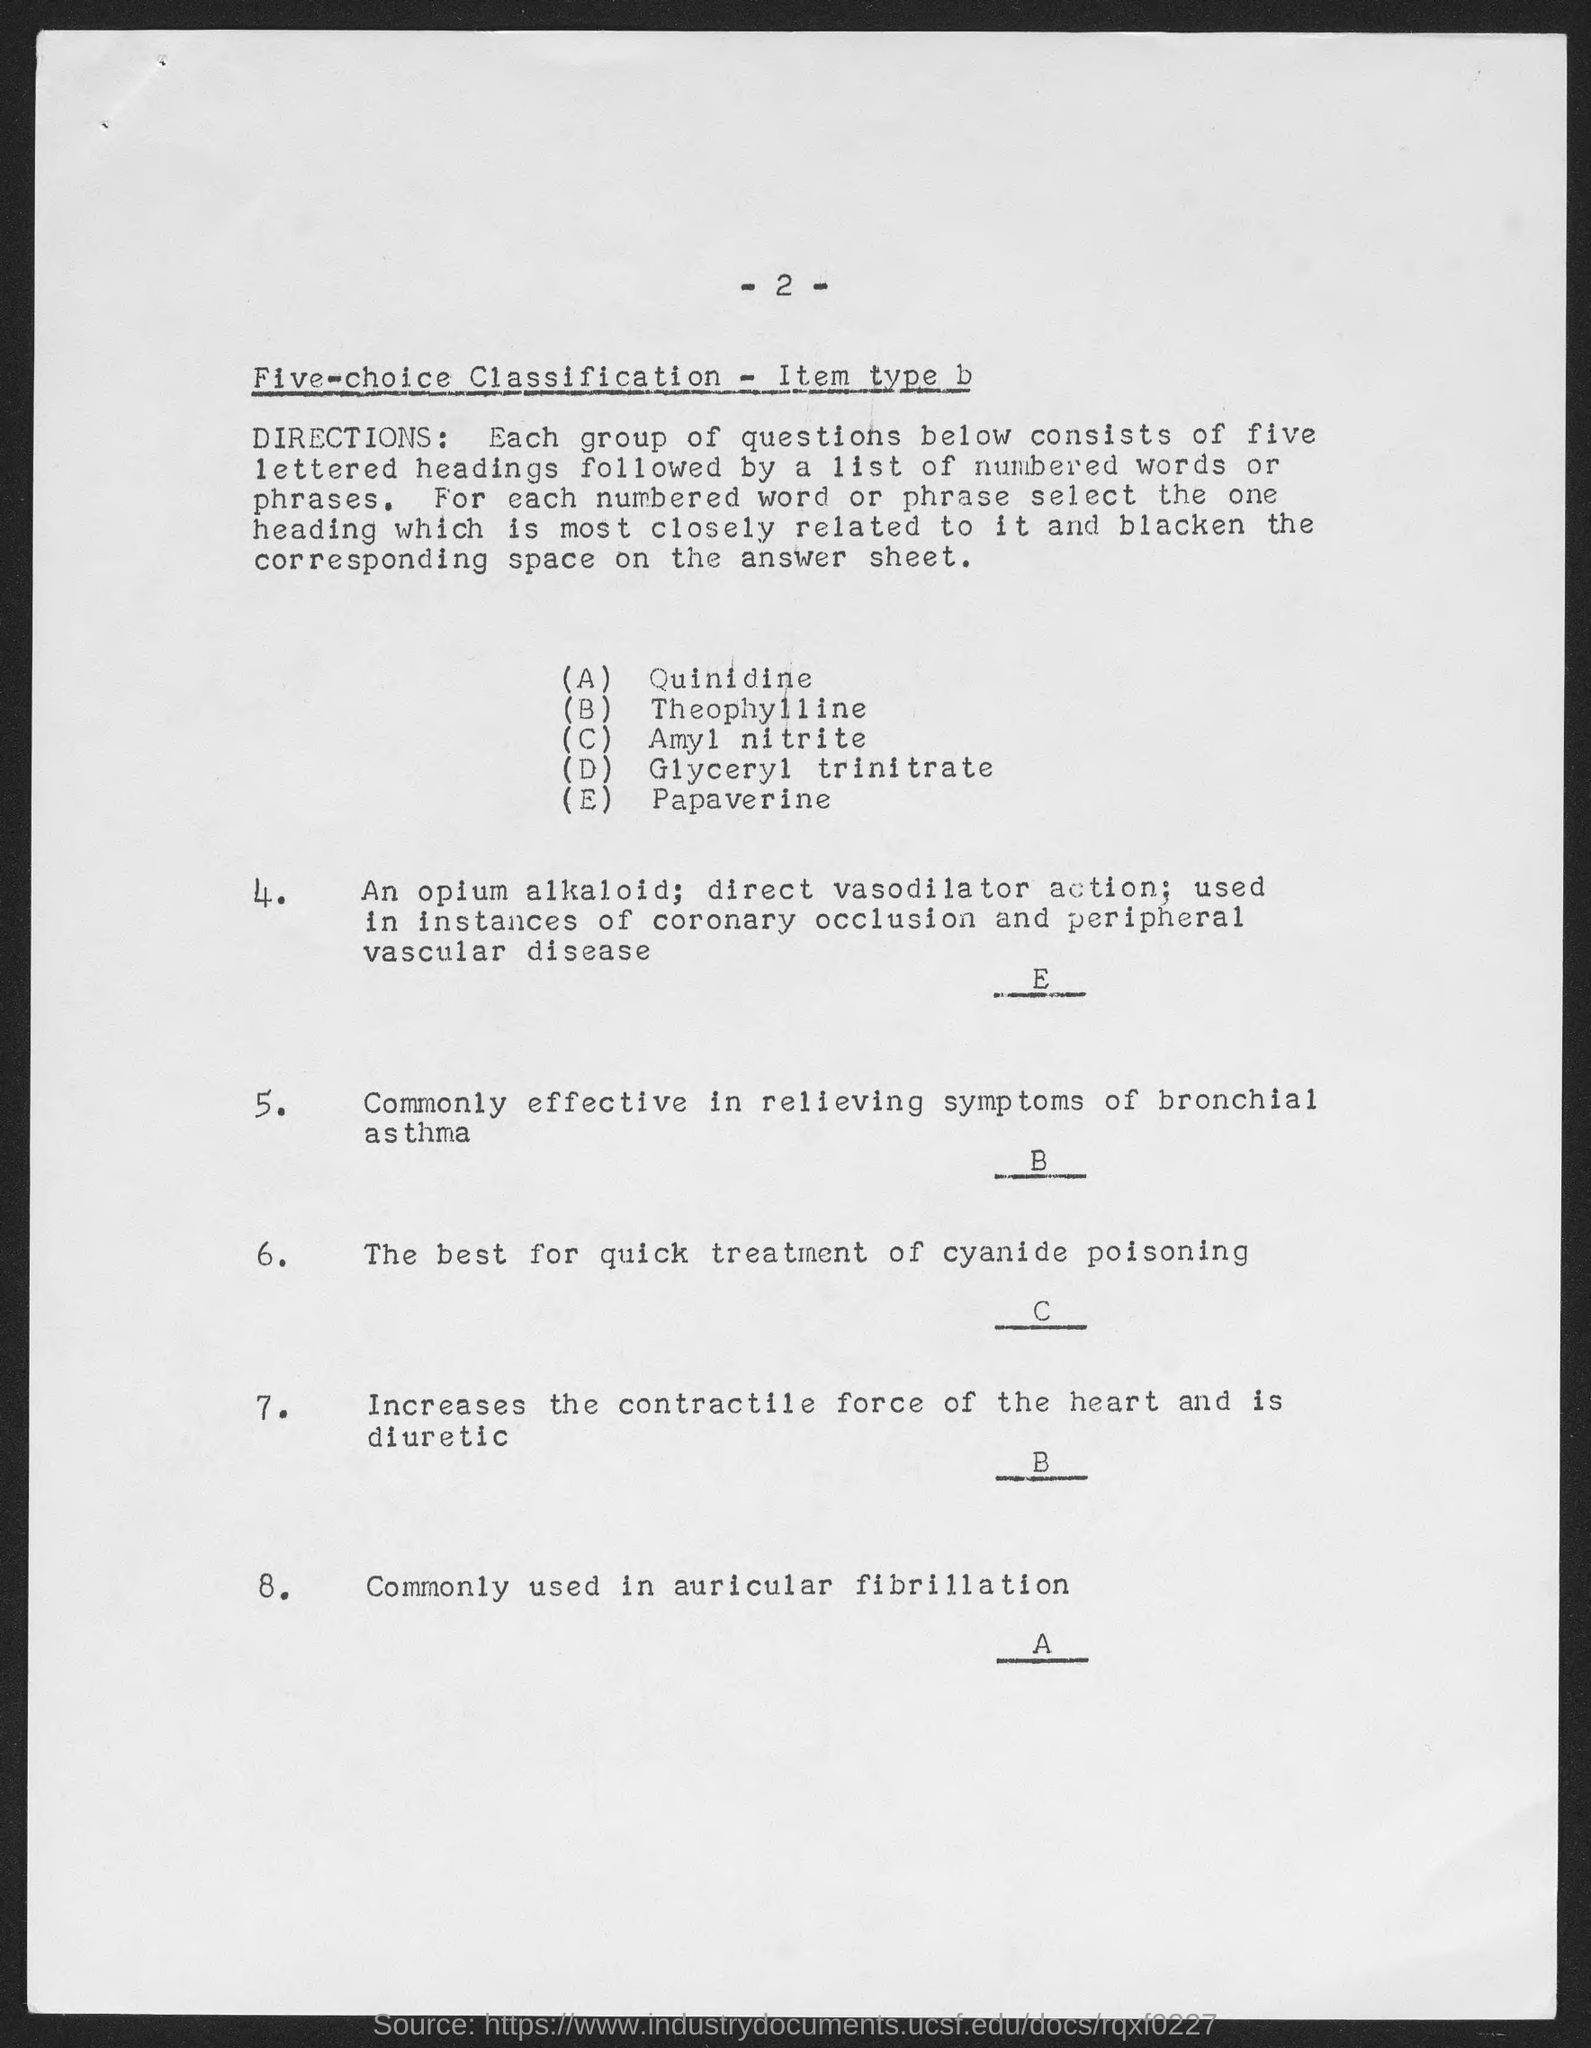Mention the page number shown in the top of the document?
Offer a terse response. -2-. What is the first lettered heading shown in the document ?
Give a very brief answer. Quinidine. Which heading is represented by the letter 'E' ?
Your answer should be compact. Papaverine. Which heading is represented by the letter 'A' ?
Your answer should be compact. QUINIDINE. Which heading is represented by the letter 'D' ?
Offer a terse response. Glyceryl trinitrate. 